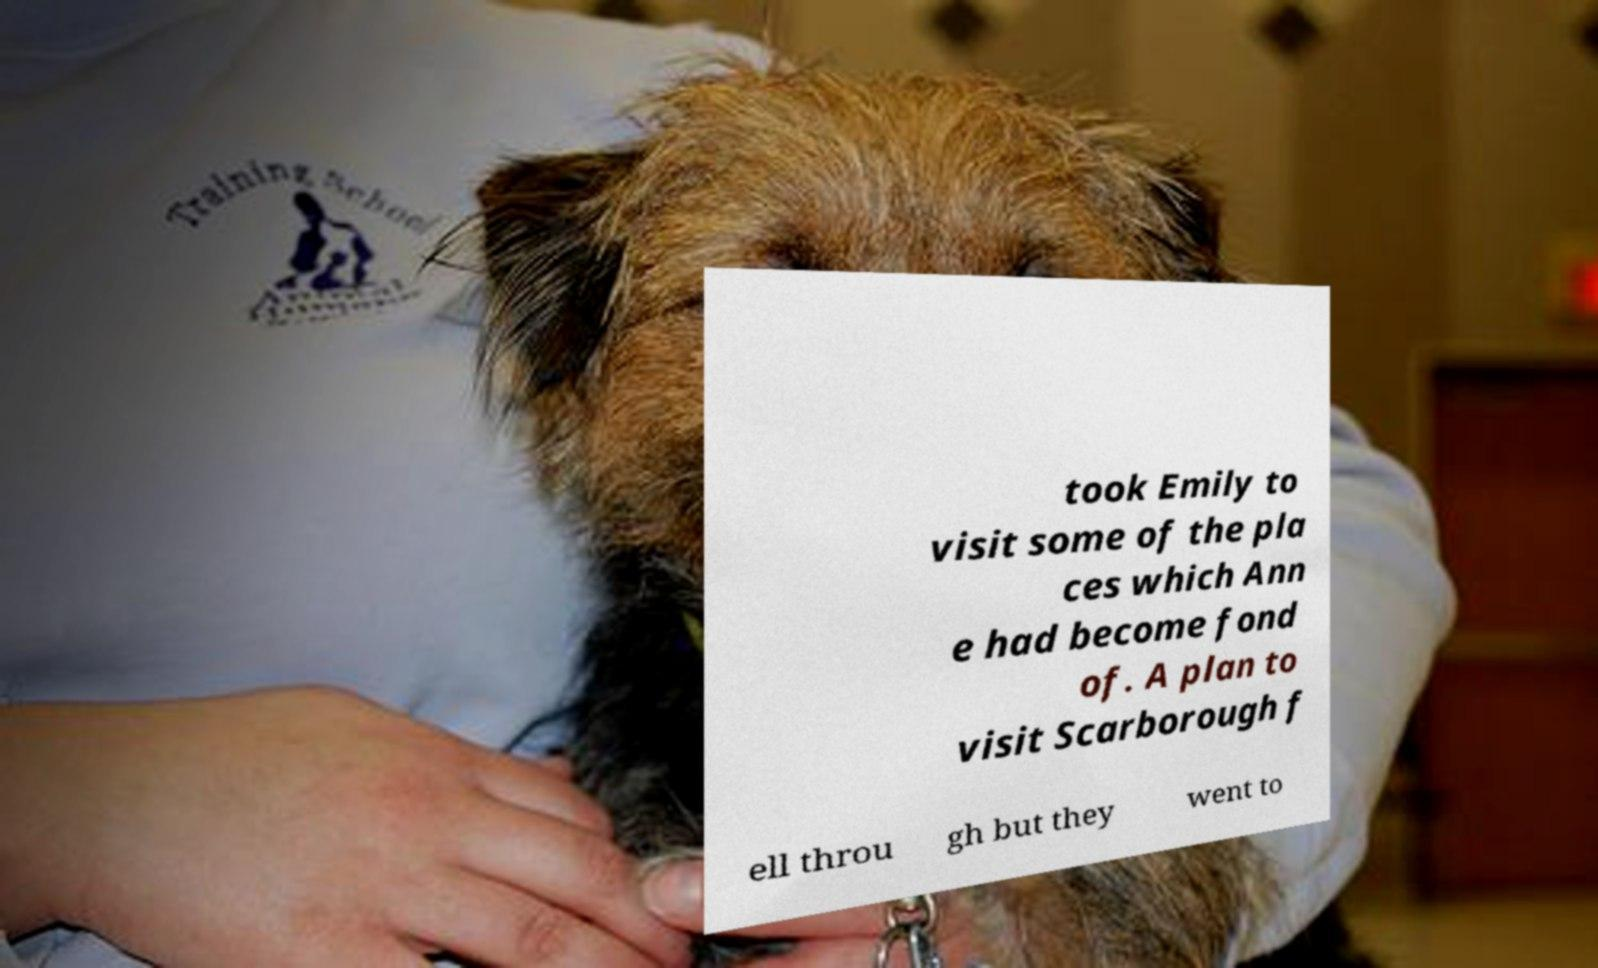Could you extract and type out the text from this image? took Emily to visit some of the pla ces which Ann e had become fond of. A plan to visit Scarborough f ell throu gh but they went to 